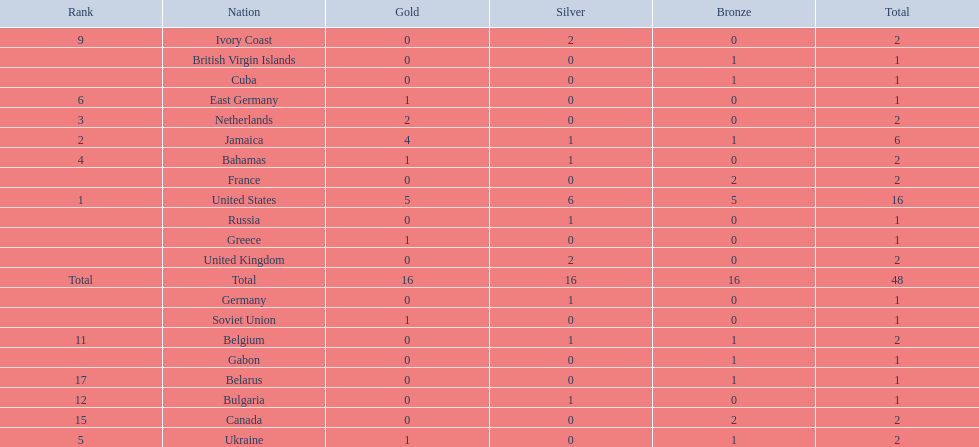How many nations won at least two gold medals? 3. 